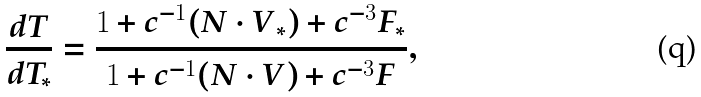<formula> <loc_0><loc_0><loc_500><loc_500>\frac { d T } { d T _ { * } } = \frac { 1 + c ^ { - 1 } ( { N \cdot V } _ { * } ) + c ^ { - 3 } F _ { * } } { 1 + c ^ { - 1 } ( { N \cdot V } ) + c ^ { - 3 } F } ,</formula> 